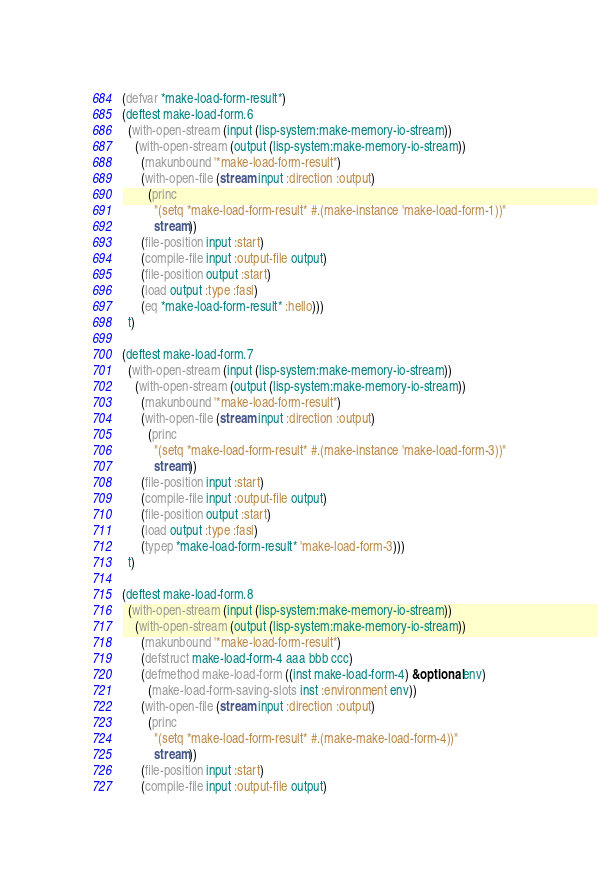Convert code to text. <code><loc_0><loc_0><loc_500><loc_500><_Lisp_>
(defvar *make-load-form-result*)
(deftest make-load-form.6
  (with-open-stream (input (lisp-system:make-memory-io-stream))
    (with-open-stream (output (lisp-system:make-memory-io-stream))
      (makunbound '*make-load-form-result*)
      (with-open-file (stream input :direction :output)
        (princ
          "(setq *make-load-form-result* #.(make-instance 'make-load-form-1))"
          stream))
      (file-position input :start)
      (compile-file input :output-file output)
      (file-position output :start)
      (load output :type :fasl)
      (eq *make-load-form-result* :hello)))
  t)

(deftest make-load-form.7
  (with-open-stream (input (lisp-system:make-memory-io-stream))
    (with-open-stream (output (lisp-system:make-memory-io-stream))
      (makunbound '*make-load-form-result*)
      (with-open-file (stream input :direction :output)
        (princ
          "(setq *make-load-form-result* #.(make-instance 'make-load-form-3))"
          stream))
      (file-position input :start)
      (compile-file input :output-file output)
      (file-position output :start)
      (load output :type :fasl)
      (typep *make-load-form-result* 'make-load-form-3)))
  t)

(deftest make-load-form.8
  (with-open-stream (input (lisp-system:make-memory-io-stream))
    (with-open-stream (output (lisp-system:make-memory-io-stream))
      (makunbound '*make-load-form-result*)
      (defstruct make-load-form-4 aaa bbb ccc)
      (defmethod make-load-form ((inst make-load-form-4) &optional env)
        (make-load-form-saving-slots inst :environment env))
      (with-open-file (stream input :direction :output)
        (princ
          "(setq *make-load-form-result* #.(make-make-load-form-4))"
          stream))
      (file-position input :start)
      (compile-file input :output-file output)</code> 